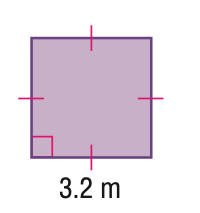Answer the mathemtical geometry problem and directly provide the correct option letter.
Question: Find the perimeter of the parallelogram. Round to the nearest tenth if necessary.
Choices: A: 3.2 B: 6.4 C: 12.8 D: 16 C 